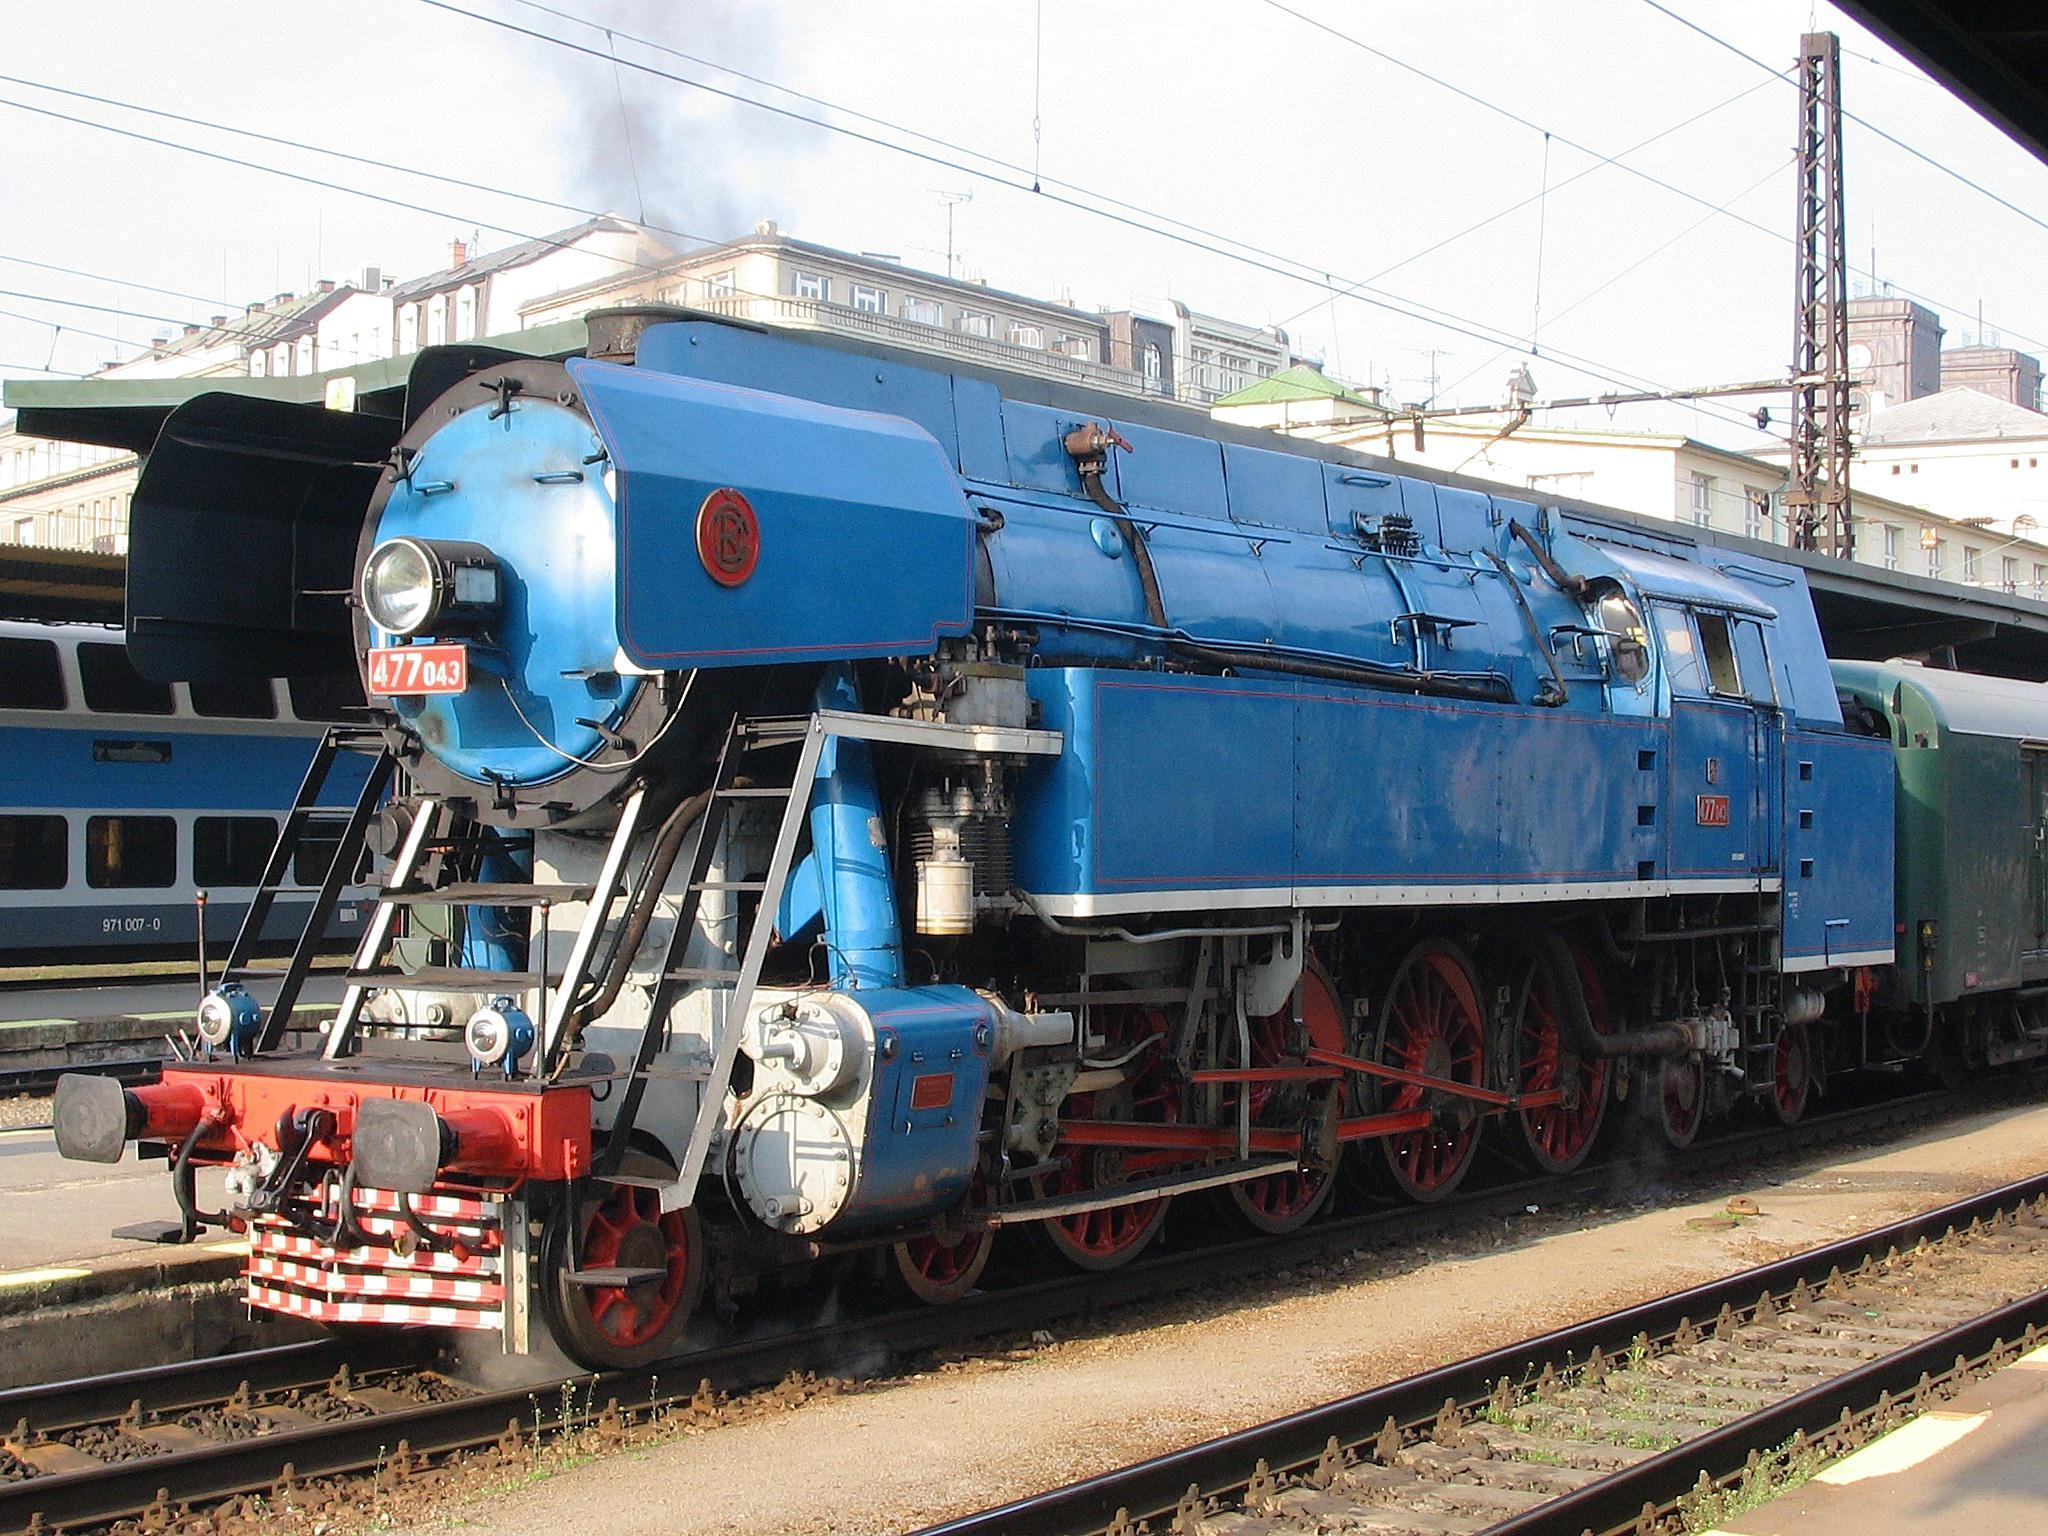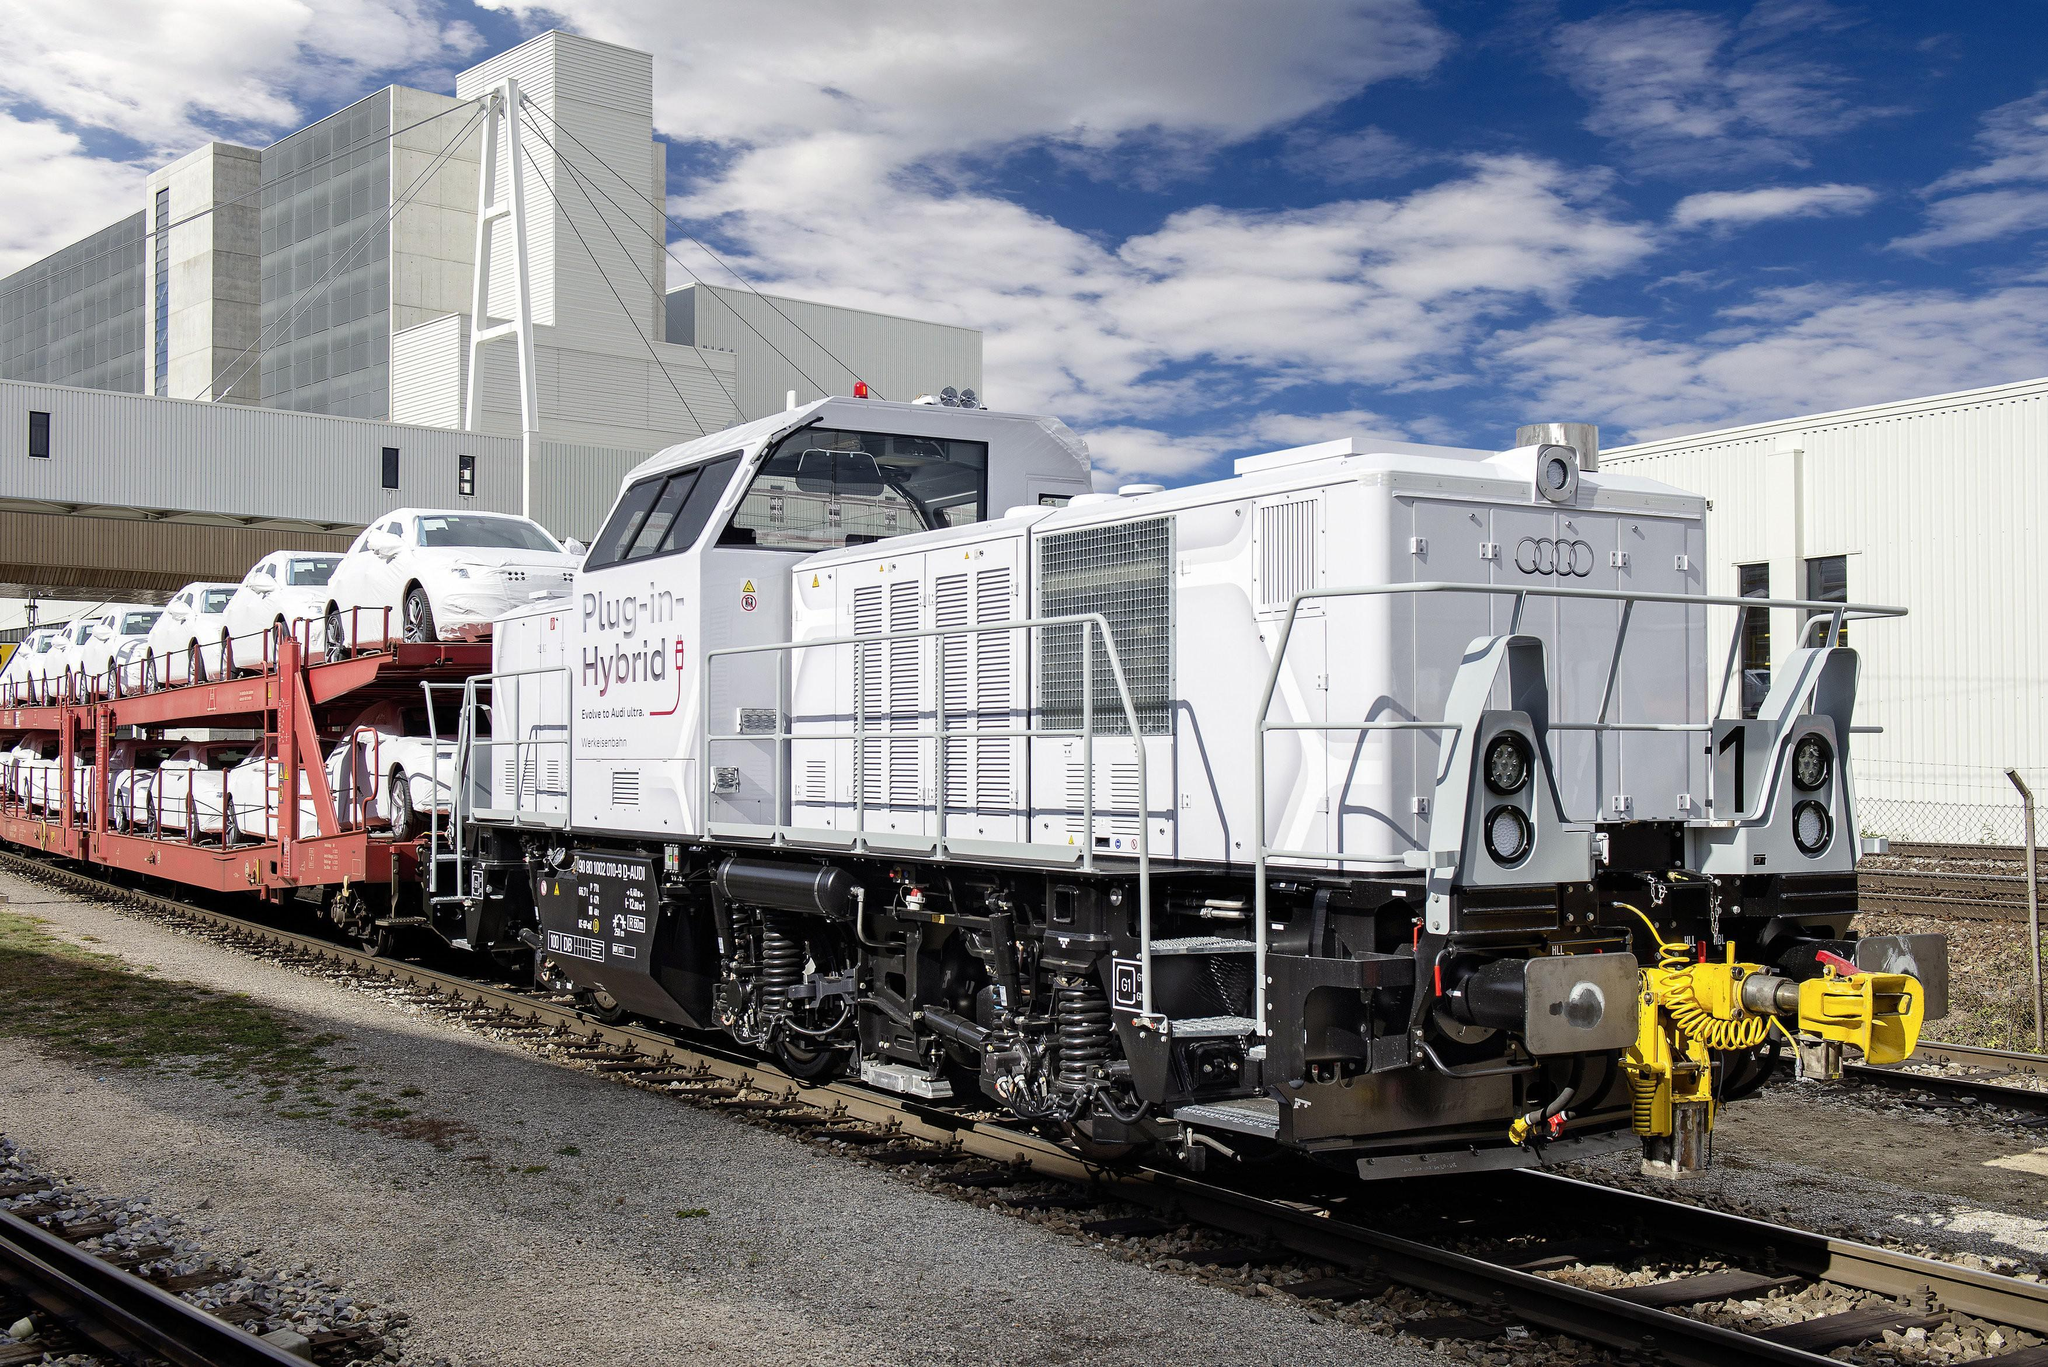The first image is the image on the left, the second image is the image on the right. Given the left and right images, does the statement "1 locomotive has CSX painted on the side." hold true? Answer yes or no. No. 